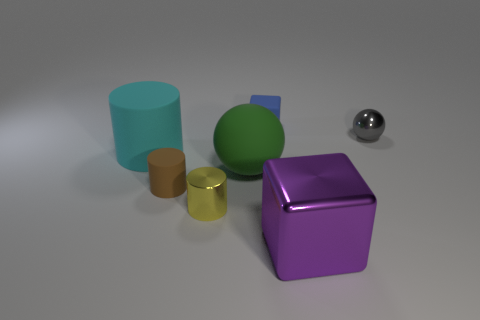There is a cylinder that is behind the large rubber object right of the small rubber thing left of the tiny metallic cylinder; what is its size?
Provide a short and direct response. Large. Is the number of small green objects greater than the number of large spheres?
Provide a succinct answer. No. Does the sphere left of the tiny blue cube have the same color as the small matte block that is right of the yellow metal cylinder?
Give a very brief answer. No. Is the material of the object right of the purple shiny cube the same as the ball on the left side of the tiny blue block?
Give a very brief answer. No. How many blue blocks have the same size as the cyan matte object?
Offer a very short reply. 0. Are there fewer tiny gray metal balls than large red matte cylinders?
Provide a succinct answer. No. The small matte thing behind the big rubber thing right of the yellow object is what shape?
Offer a very short reply. Cube. The blue object that is the same size as the metallic sphere is what shape?
Give a very brief answer. Cube. Is there a yellow thing of the same shape as the small blue matte object?
Provide a succinct answer. No. What is the material of the cyan thing?
Your answer should be compact. Rubber. 